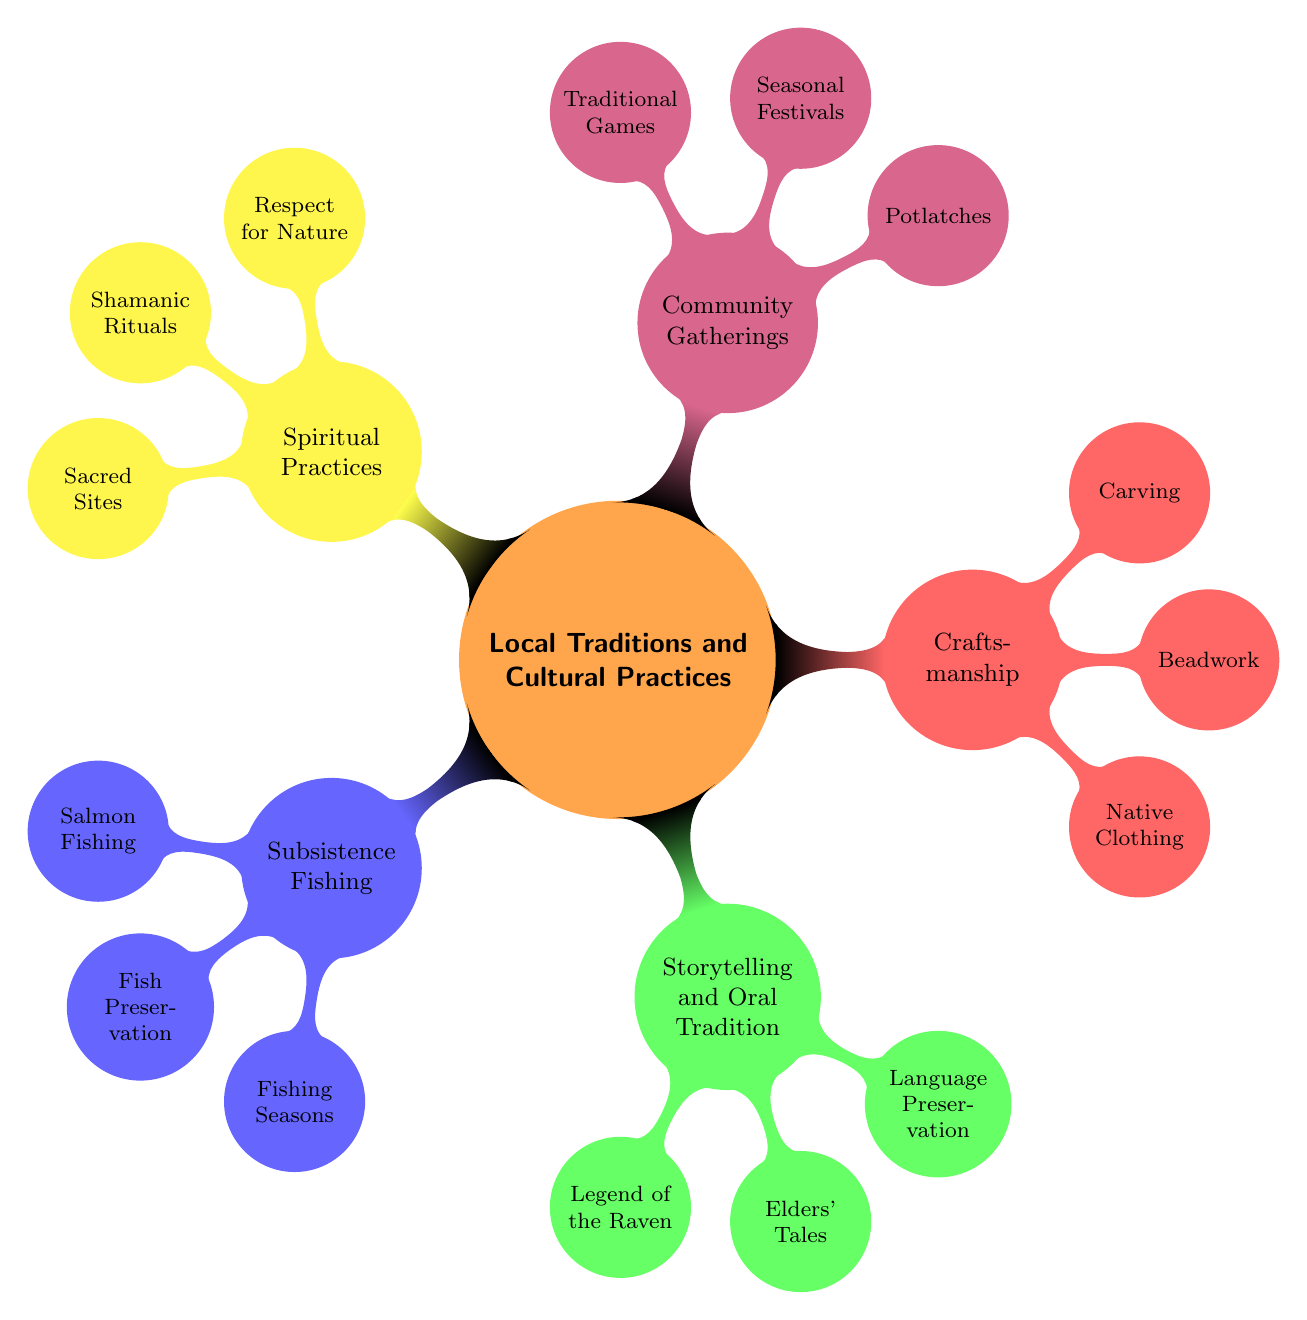What is the main topic of the mind map? The central node of the mind map is labeled "Local Traditions and Cultural Practices," indicating that this is the main topic discussed in the diagram.
Answer: Local Traditions and Cultural Practices How many main categories are there in the diagram? The diagram has five main categories branching from the central node: Subsistence Fishing, Storytelling and Oral Tradition, Craftsmanship, Community Gatherings, and Spiritual Practices. Therefore, the number of main categories is five.
Answer: 5 What is one form of fishing mentioned in the diagram? Under the category of Subsistence Fishing, one specific type of fishing listed is "Salmon Fishing." This indicates that salmon fishing is recognized as a local tradition.
Answer: Salmon Fishing What cultural games are mentioned in relation to community gatherings? The node under Community Gatherings lists "Traditional Games" as one of the key aspects. This means that traditional games are important cultural practices within community gatherings.
Answer: Traditional Games What does "Language Preservation" aim to achieve? The node labeled Language Preservation expresses efforts to keep the native language alive through stories. Therefore, its goal is to maintain the native language.
Answer: Maintain the native language Which category includes "Elders' Tales"? "Elders' Tales" is located within the Storytelling and Oral Tradition category. This indicates that this form of storytelling is important in preserving cultural heritage.
Answer: Storytelling and Oral Tradition How does the diagram express respect for nature? The node labeled "Respect for Nature" is listed under Spiritual Practices, showing that this belief system emphasizes honoring the environment as a key spiritual practice.
Answer: Spiritual Practices What are potlatches? Potlatches are defined in the diagram as celebrations involving feasting, dancing, and socializing, indicating their significant cultural role in the community.
Answer: Celebrations involving feasting, dancing, and socializing What traditional craftsmanship item involves intricate designs? The Beadwork node under Craftsmanship refers to the creation of items with intricate designs and patterns unique to the community, highlighting the artistry involved.
Answer: Beadwork 